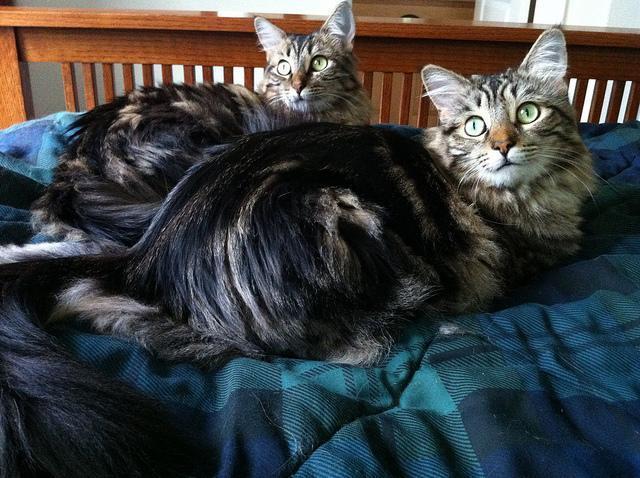How many pair of eyes do you see?
Give a very brief answer. 2. How many cats are in the picture?
Give a very brief answer. 2. How many doors does the refrigerator have?
Give a very brief answer. 0. 